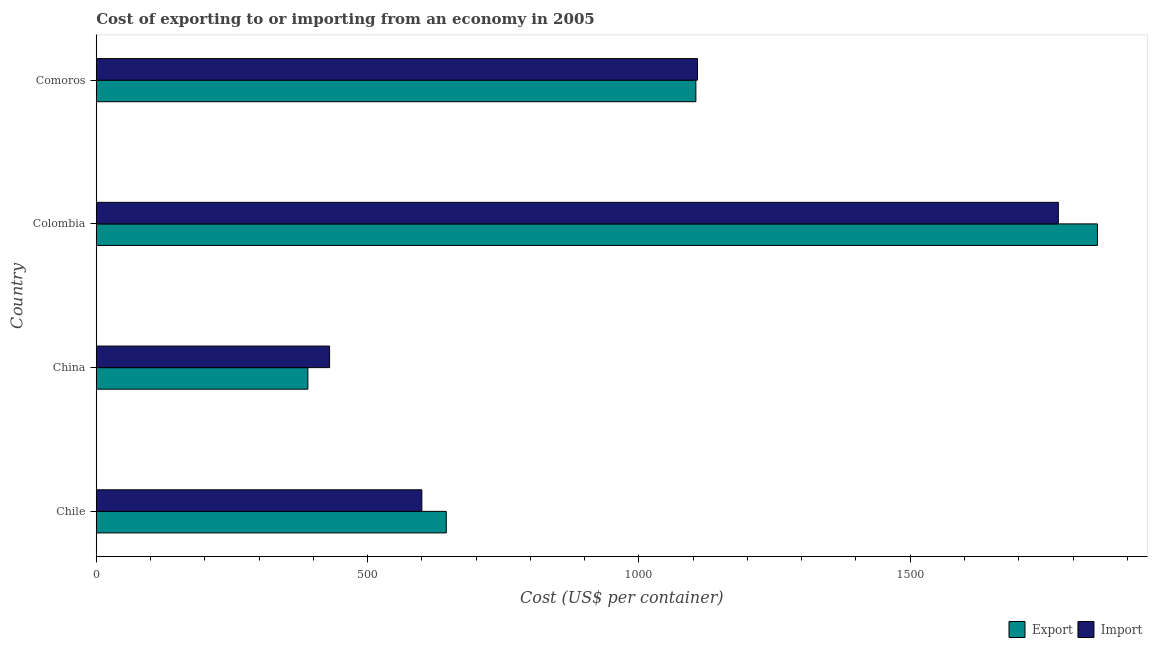Are the number of bars per tick equal to the number of legend labels?
Make the answer very short. Yes. Are the number of bars on each tick of the Y-axis equal?
Keep it short and to the point. Yes. How many bars are there on the 1st tick from the bottom?
Keep it short and to the point. 2. In how many cases, is the number of bars for a given country not equal to the number of legend labels?
Your answer should be very brief. 0. What is the export cost in Chile?
Offer a terse response. 645. Across all countries, what is the maximum export cost?
Provide a short and direct response. 1845. Across all countries, what is the minimum export cost?
Keep it short and to the point. 390. In which country was the export cost minimum?
Ensure brevity in your answer.  China. What is the total export cost in the graph?
Ensure brevity in your answer.  3985. What is the difference between the export cost in China and that in Comoros?
Offer a very short reply. -715. What is the difference between the export cost in Comoros and the import cost in Chile?
Ensure brevity in your answer.  505. What is the average export cost per country?
Make the answer very short. 996.25. What is the ratio of the export cost in Colombia to that in Comoros?
Your answer should be very brief. 1.67. Is the import cost in Chile less than that in Colombia?
Offer a very short reply. Yes. Is the difference between the export cost in Chile and China greater than the difference between the import cost in Chile and China?
Provide a succinct answer. Yes. What is the difference between the highest and the second highest export cost?
Give a very brief answer. 740. What is the difference between the highest and the lowest export cost?
Provide a short and direct response. 1455. Is the sum of the export cost in China and Colombia greater than the maximum import cost across all countries?
Keep it short and to the point. Yes. What does the 2nd bar from the top in China represents?
Ensure brevity in your answer.  Export. What does the 1st bar from the bottom in Chile represents?
Give a very brief answer. Export. Are all the bars in the graph horizontal?
Ensure brevity in your answer.  Yes. What is the difference between two consecutive major ticks on the X-axis?
Make the answer very short. 500. Does the graph contain grids?
Offer a very short reply. No. How many legend labels are there?
Your response must be concise. 2. What is the title of the graph?
Your answer should be very brief. Cost of exporting to or importing from an economy in 2005. What is the label or title of the X-axis?
Offer a terse response. Cost (US$ per container). What is the label or title of the Y-axis?
Your response must be concise. Country. What is the Cost (US$ per container) in Export in Chile?
Your answer should be compact. 645. What is the Cost (US$ per container) of Import in Chile?
Provide a succinct answer. 600. What is the Cost (US$ per container) in Export in China?
Offer a terse response. 390. What is the Cost (US$ per container) of Import in China?
Offer a very short reply. 430. What is the Cost (US$ per container) in Export in Colombia?
Make the answer very short. 1845. What is the Cost (US$ per container) in Import in Colombia?
Make the answer very short. 1773. What is the Cost (US$ per container) of Export in Comoros?
Give a very brief answer. 1105. What is the Cost (US$ per container) in Import in Comoros?
Provide a succinct answer. 1108. Across all countries, what is the maximum Cost (US$ per container) in Export?
Give a very brief answer. 1845. Across all countries, what is the maximum Cost (US$ per container) of Import?
Provide a succinct answer. 1773. Across all countries, what is the minimum Cost (US$ per container) of Export?
Your response must be concise. 390. Across all countries, what is the minimum Cost (US$ per container) of Import?
Your answer should be very brief. 430. What is the total Cost (US$ per container) of Export in the graph?
Provide a succinct answer. 3985. What is the total Cost (US$ per container) in Import in the graph?
Your response must be concise. 3911. What is the difference between the Cost (US$ per container) in Export in Chile and that in China?
Your answer should be compact. 255. What is the difference between the Cost (US$ per container) in Import in Chile and that in China?
Keep it short and to the point. 170. What is the difference between the Cost (US$ per container) in Export in Chile and that in Colombia?
Keep it short and to the point. -1200. What is the difference between the Cost (US$ per container) of Import in Chile and that in Colombia?
Keep it short and to the point. -1173. What is the difference between the Cost (US$ per container) in Export in Chile and that in Comoros?
Offer a very short reply. -460. What is the difference between the Cost (US$ per container) of Import in Chile and that in Comoros?
Offer a terse response. -508. What is the difference between the Cost (US$ per container) in Export in China and that in Colombia?
Your response must be concise. -1455. What is the difference between the Cost (US$ per container) of Import in China and that in Colombia?
Give a very brief answer. -1343. What is the difference between the Cost (US$ per container) of Export in China and that in Comoros?
Keep it short and to the point. -715. What is the difference between the Cost (US$ per container) of Import in China and that in Comoros?
Your answer should be very brief. -678. What is the difference between the Cost (US$ per container) of Export in Colombia and that in Comoros?
Ensure brevity in your answer.  740. What is the difference between the Cost (US$ per container) of Import in Colombia and that in Comoros?
Your response must be concise. 665. What is the difference between the Cost (US$ per container) in Export in Chile and the Cost (US$ per container) in Import in China?
Keep it short and to the point. 215. What is the difference between the Cost (US$ per container) of Export in Chile and the Cost (US$ per container) of Import in Colombia?
Your response must be concise. -1128. What is the difference between the Cost (US$ per container) in Export in Chile and the Cost (US$ per container) in Import in Comoros?
Give a very brief answer. -463. What is the difference between the Cost (US$ per container) of Export in China and the Cost (US$ per container) of Import in Colombia?
Your answer should be compact. -1383. What is the difference between the Cost (US$ per container) in Export in China and the Cost (US$ per container) in Import in Comoros?
Provide a succinct answer. -718. What is the difference between the Cost (US$ per container) in Export in Colombia and the Cost (US$ per container) in Import in Comoros?
Give a very brief answer. 737. What is the average Cost (US$ per container) in Export per country?
Provide a short and direct response. 996.25. What is the average Cost (US$ per container) in Import per country?
Your answer should be very brief. 977.75. What is the difference between the Cost (US$ per container) in Export and Cost (US$ per container) in Import in Chile?
Your answer should be very brief. 45. What is the ratio of the Cost (US$ per container) in Export in Chile to that in China?
Offer a very short reply. 1.65. What is the ratio of the Cost (US$ per container) in Import in Chile to that in China?
Your answer should be compact. 1.4. What is the ratio of the Cost (US$ per container) in Export in Chile to that in Colombia?
Keep it short and to the point. 0.35. What is the ratio of the Cost (US$ per container) of Import in Chile to that in Colombia?
Offer a very short reply. 0.34. What is the ratio of the Cost (US$ per container) of Export in Chile to that in Comoros?
Your answer should be very brief. 0.58. What is the ratio of the Cost (US$ per container) of Import in Chile to that in Comoros?
Offer a terse response. 0.54. What is the ratio of the Cost (US$ per container) of Export in China to that in Colombia?
Keep it short and to the point. 0.21. What is the ratio of the Cost (US$ per container) in Import in China to that in Colombia?
Give a very brief answer. 0.24. What is the ratio of the Cost (US$ per container) in Export in China to that in Comoros?
Provide a succinct answer. 0.35. What is the ratio of the Cost (US$ per container) in Import in China to that in Comoros?
Offer a terse response. 0.39. What is the ratio of the Cost (US$ per container) in Export in Colombia to that in Comoros?
Your answer should be compact. 1.67. What is the ratio of the Cost (US$ per container) in Import in Colombia to that in Comoros?
Your response must be concise. 1.6. What is the difference between the highest and the second highest Cost (US$ per container) of Export?
Your response must be concise. 740. What is the difference between the highest and the second highest Cost (US$ per container) in Import?
Your response must be concise. 665. What is the difference between the highest and the lowest Cost (US$ per container) of Export?
Your answer should be compact. 1455. What is the difference between the highest and the lowest Cost (US$ per container) of Import?
Your answer should be compact. 1343. 